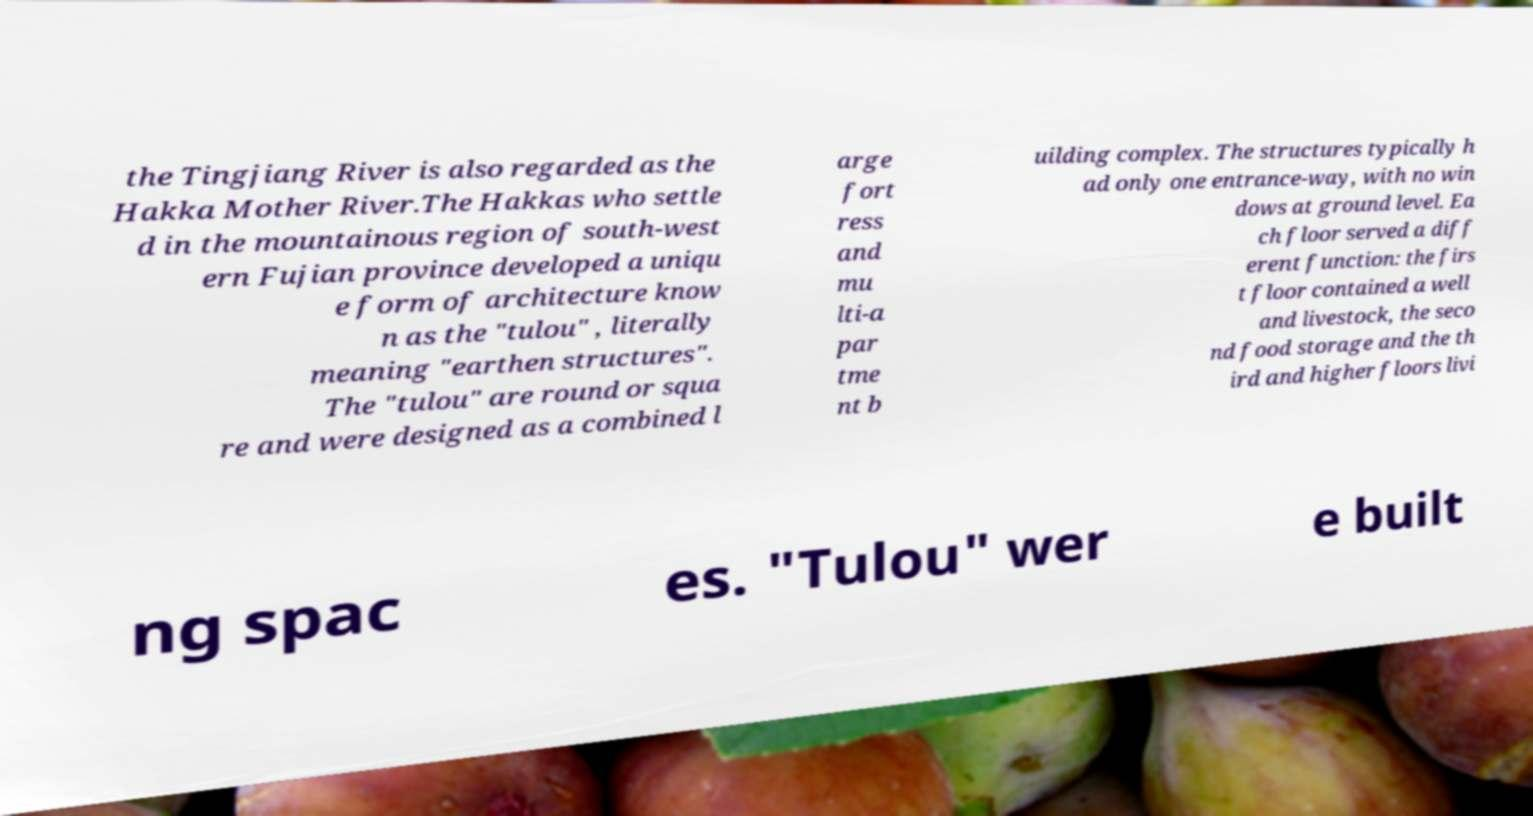Could you extract and type out the text from this image? the Tingjiang River is also regarded as the Hakka Mother River.The Hakkas who settle d in the mountainous region of south-west ern Fujian province developed a uniqu e form of architecture know n as the "tulou" , literally meaning "earthen structures". The "tulou" are round or squa re and were designed as a combined l arge fort ress and mu lti-a par tme nt b uilding complex. The structures typically h ad only one entrance-way, with no win dows at ground level. Ea ch floor served a diff erent function: the firs t floor contained a well and livestock, the seco nd food storage and the th ird and higher floors livi ng spac es. "Tulou" wer e built 